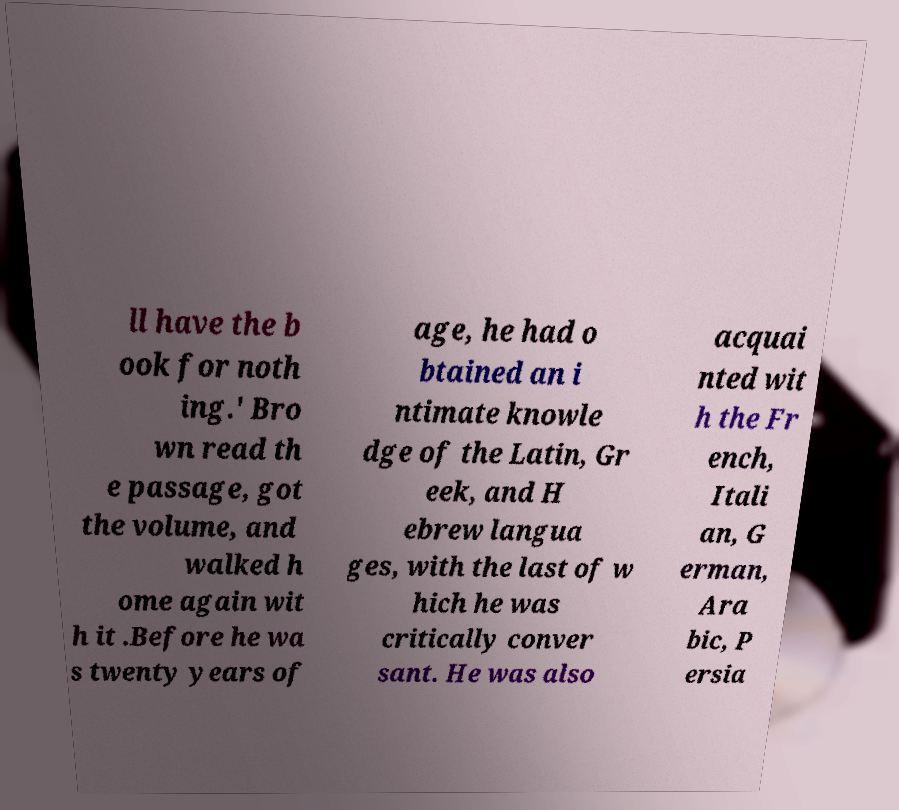I need the written content from this picture converted into text. Can you do that? ll have the b ook for noth ing.' Bro wn read th e passage, got the volume, and walked h ome again wit h it .Before he wa s twenty years of age, he had o btained an i ntimate knowle dge of the Latin, Gr eek, and H ebrew langua ges, with the last of w hich he was critically conver sant. He was also acquai nted wit h the Fr ench, Itali an, G erman, Ara bic, P ersia 